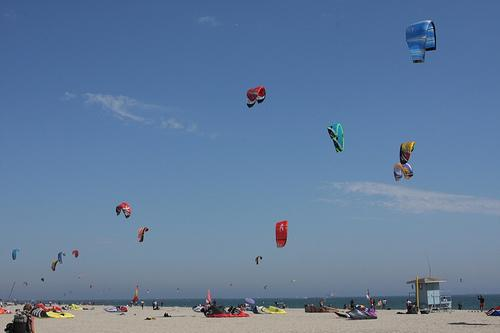Express creatively the atmosphere in the image. Kaleidoscopic kites dance gracefully in the sky, as sun-seeking souls surrender to the warm embrace of the golden sands leaving the azure waters lapping gently against the seashore. Provide a detailed description of the beach in the image. A sandy beach filled with sunbathing people, flying kites in the air, lifeguard tower, beach maintenance house, blue ocean as a backdrop, and a hazy sky above. What is the primary focus of the image and what is happening in that focus? The primary focus is the beach, where a multitude of people are sunbathing, flying kites, and enjoying the seaside on a sunny day. What are some notable objects in the image related to water and beach? Lifeguard tower, ocean, people on red towel, parasail in the ocean, and a gray jetski can be observed in the image. Write a brief description of the sky in the image. A bright blue sky with few white clouds, filled with colorful kites flying high and people enjoying on the beach below.  Describe the kites flying in the sky. Various colorful kites, including a red kite, a blue kite with a white stripe, and a multicolored kite, can be seen flying against the clear blue sky. Briefly describe the scene involving the people on the beach. People are lying down, sunbathing on the sandy beach, with some on a red towel, while others are busy flying kites under the bright blue sky. Mention the primary activity taking place at the beach in the picture. People are sunbathing, laying on the beach, flying kites, and enjoying the sunny day by the ocean. Incorporate clouds and kites into a description of the scene. Under the blue sky with scattered white clouds, numerous colorful kites in various shapes and sizes are sailing effortlessly across the marvelous beach scene. Mention something unique happening on the beach in the image. A man standing at the edge flying a kite, while a woman lay relaxing in the sand, creates a uniquely serene beach scenario amid the touristic chaos. 